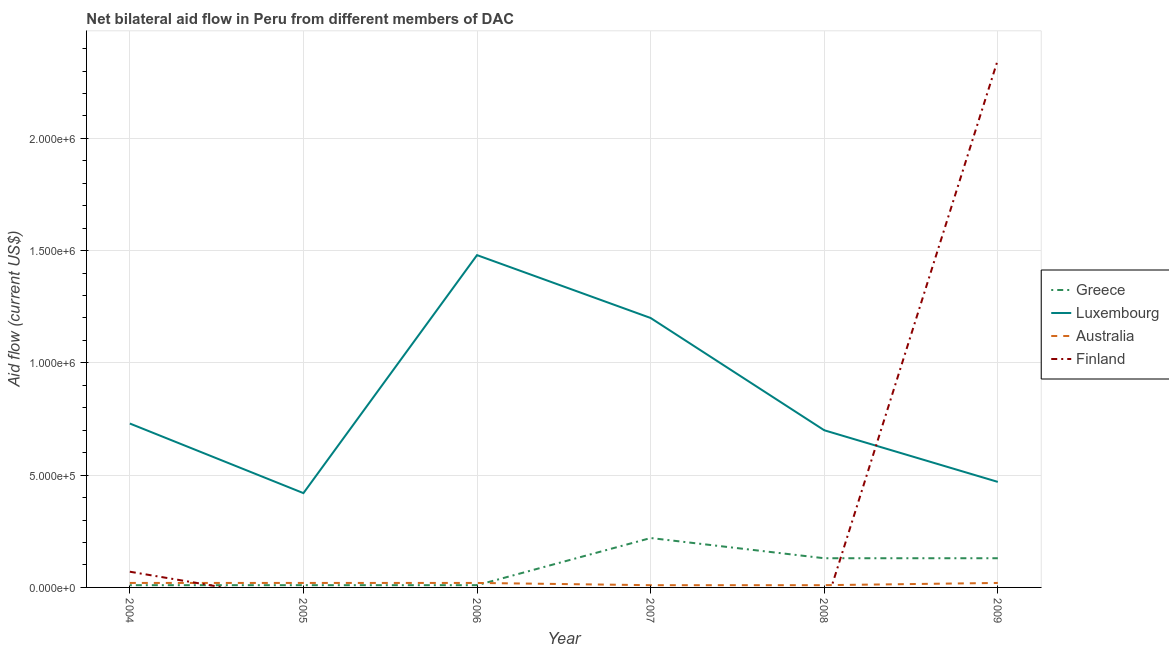Is the number of lines equal to the number of legend labels?
Your answer should be very brief. No. What is the amount of aid given by australia in 2009?
Offer a very short reply. 2.00e+04. Across all years, what is the maximum amount of aid given by greece?
Keep it short and to the point. 2.20e+05. Across all years, what is the minimum amount of aid given by greece?
Give a very brief answer. 10000. In which year was the amount of aid given by finland maximum?
Your answer should be very brief. 2009. What is the total amount of aid given by luxembourg in the graph?
Your answer should be very brief. 5.00e+06. What is the difference between the amount of aid given by luxembourg in 2005 and that in 2009?
Provide a succinct answer. -5.00e+04. What is the difference between the amount of aid given by australia in 2004 and the amount of aid given by greece in 2005?
Offer a terse response. 10000. What is the average amount of aid given by finland per year?
Your response must be concise. 4.03e+05. In the year 2004, what is the difference between the amount of aid given by australia and amount of aid given by greece?
Your answer should be compact. 10000. In how many years, is the amount of aid given by greece greater than 1400000 US$?
Keep it short and to the point. 0. What is the ratio of the amount of aid given by australia in 2005 to that in 2009?
Make the answer very short. 1. Is the amount of aid given by australia in 2004 less than that in 2007?
Your response must be concise. No. What is the difference between the highest and the second highest amount of aid given by greece?
Your answer should be compact. 9.00e+04. What is the difference between the highest and the lowest amount of aid given by australia?
Your answer should be compact. 10000. How many years are there in the graph?
Provide a short and direct response. 6. Are the values on the major ticks of Y-axis written in scientific E-notation?
Offer a very short reply. Yes. Does the graph contain any zero values?
Make the answer very short. Yes. Does the graph contain grids?
Provide a short and direct response. Yes. Where does the legend appear in the graph?
Your answer should be very brief. Center right. How many legend labels are there?
Ensure brevity in your answer.  4. How are the legend labels stacked?
Ensure brevity in your answer.  Vertical. What is the title of the graph?
Provide a short and direct response. Net bilateral aid flow in Peru from different members of DAC. Does "Terrestrial protected areas" appear as one of the legend labels in the graph?
Offer a very short reply. No. What is the label or title of the X-axis?
Give a very brief answer. Year. What is the Aid flow (current US$) of Greece in 2004?
Your answer should be very brief. 10000. What is the Aid flow (current US$) of Luxembourg in 2004?
Give a very brief answer. 7.30e+05. What is the Aid flow (current US$) in Greece in 2005?
Ensure brevity in your answer.  10000. What is the Aid flow (current US$) of Australia in 2005?
Keep it short and to the point. 2.00e+04. What is the Aid flow (current US$) of Greece in 2006?
Offer a very short reply. 10000. What is the Aid flow (current US$) in Luxembourg in 2006?
Keep it short and to the point. 1.48e+06. What is the Aid flow (current US$) of Australia in 2006?
Ensure brevity in your answer.  2.00e+04. What is the Aid flow (current US$) in Luxembourg in 2007?
Your answer should be very brief. 1.20e+06. What is the Aid flow (current US$) of Australia in 2007?
Provide a succinct answer. 10000. What is the Aid flow (current US$) of Finland in 2007?
Offer a very short reply. 0. What is the Aid flow (current US$) of Finland in 2008?
Ensure brevity in your answer.  0. What is the Aid flow (current US$) of Greece in 2009?
Ensure brevity in your answer.  1.30e+05. What is the Aid flow (current US$) of Finland in 2009?
Your answer should be very brief. 2.35e+06. Across all years, what is the maximum Aid flow (current US$) in Luxembourg?
Ensure brevity in your answer.  1.48e+06. Across all years, what is the maximum Aid flow (current US$) in Australia?
Your answer should be compact. 2.00e+04. Across all years, what is the maximum Aid flow (current US$) in Finland?
Make the answer very short. 2.35e+06. Across all years, what is the minimum Aid flow (current US$) of Luxembourg?
Provide a short and direct response. 4.20e+05. Across all years, what is the minimum Aid flow (current US$) of Australia?
Provide a short and direct response. 10000. Across all years, what is the minimum Aid flow (current US$) in Finland?
Offer a very short reply. 0. What is the total Aid flow (current US$) of Greece in the graph?
Give a very brief answer. 5.10e+05. What is the total Aid flow (current US$) of Luxembourg in the graph?
Keep it short and to the point. 5.00e+06. What is the total Aid flow (current US$) of Australia in the graph?
Keep it short and to the point. 1.00e+05. What is the total Aid flow (current US$) in Finland in the graph?
Your answer should be compact. 2.42e+06. What is the difference between the Aid flow (current US$) of Luxembourg in 2004 and that in 2006?
Provide a short and direct response. -7.50e+05. What is the difference between the Aid flow (current US$) of Australia in 2004 and that in 2006?
Your answer should be compact. 0. What is the difference between the Aid flow (current US$) of Greece in 2004 and that in 2007?
Your response must be concise. -2.10e+05. What is the difference between the Aid flow (current US$) in Luxembourg in 2004 and that in 2007?
Your answer should be compact. -4.70e+05. What is the difference between the Aid flow (current US$) of Australia in 2004 and that in 2007?
Give a very brief answer. 10000. What is the difference between the Aid flow (current US$) of Luxembourg in 2004 and that in 2008?
Keep it short and to the point. 3.00e+04. What is the difference between the Aid flow (current US$) in Australia in 2004 and that in 2008?
Your response must be concise. 10000. What is the difference between the Aid flow (current US$) of Greece in 2004 and that in 2009?
Give a very brief answer. -1.20e+05. What is the difference between the Aid flow (current US$) of Luxembourg in 2004 and that in 2009?
Your response must be concise. 2.60e+05. What is the difference between the Aid flow (current US$) in Finland in 2004 and that in 2009?
Your response must be concise. -2.28e+06. What is the difference between the Aid flow (current US$) of Luxembourg in 2005 and that in 2006?
Offer a terse response. -1.06e+06. What is the difference between the Aid flow (current US$) of Australia in 2005 and that in 2006?
Your response must be concise. 0. What is the difference between the Aid flow (current US$) of Luxembourg in 2005 and that in 2007?
Ensure brevity in your answer.  -7.80e+05. What is the difference between the Aid flow (current US$) in Australia in 2005 and that in 2007?
Keep it short and to the point. 10000. What is the difference between the Aid flow (current US$) in Greece in 2005 and that in 2008?
Your response must be concise. -1.20e+05. What is the difference between the Aid flow (current US$) in Luxembourg in 2005 and that in 2008?
Provide a succinct answer. -2.80e+05. What is the difference between the Aid flow (current US$) of Greece in 2005 and that in 2009?
Offer a very short reply. -1.20e+05. What is the difference between the Aid flow (current US$) in Luxembourg in 2005 and that in 2009?
Provide a succinct answer. -5.00e+04. What is the difference between the Aid flow (current US$) in Luxembourg in 2006 and that in 2007?
Ensure brevity in your answer.  2.80e+05. What is the difference between the Aid flow (current US$) of Australia in 2006 and that in 2007?
Make the answer very short. 10000. What is the difference between the Aid flow (current US$) of Greece in 2006 and that in 2008?
Make the answer very short. -1.20e+05. What is the difference between the Aid flow (current US$) of Luxembourg in 2006 and that in 2008?
Make the answer very short. 7.80e+05. What is the difference between the Aid flow (current US$) of Australia in 2006 and that in 2008?
Your answer should be compact. 10000. What is the difference between the Aid flow (current US$) in Luxembourg in 2006 and that in 2009?
Offer a very short reply. 1.01e+06. What is the difference between the Aid flow (current US$) in Australia in 2006 and that in 2009?
Your answer should be very brief. 0. What is the difference between the Aid flow (current US$) in Luxembourg in 2007 and that in 2009?
Give a very brief answer. 7.30e+05. What is the difference between the Aid flow (current US$) of Australia in 2007 and that in 2009?
Your response must be concise. -10000. What is the difference between the Aid flow (current US$) in Luxembourg in 2008 and that in 2009?
Ensure brevity in your answer.  2.30e+05. What is the difference between the Aid flow (current US$) of Australia in 2008 and that in 2009?
Provide a short and direct response. -10000. What is the difference between the Aid flow (current US$) in Greece in 2004 and the Aid flow (current US$) in Luxembourg in 2005?
Ensure brevity in your answer.  -4.10e+05. What is the difference between the Aid flow (current US$) in Greece in 2004 and the Aid flow (current US$) in Australia in 2005?
Your answer should be compact. -10000. What is the difference between the Aid flow (current US$) of Luxembourg in 2004 and the Aid flow (current US$) of Australia in 2005?
Offer a terse response. 7.10e+05. What is the difference between the Aid flow (current US$) in Greece in 2004 and the Aid flow (current US$) in Luxembourg in 2006?
Make the answer very short. -1.47e+06. What is the difference between the Aid flow (current US$) of Luxembourg in 2004 and the Aid flow (current US$) of Australia in 2006?
Ensure brevity in your answer.  7.10e+05. What is the difference between the Aid flow (current US$) in Greece in 2004 and the Aid flow (current US$) in Luxembourg in 2007?
Your answer should be compact. -1.19e+06. What is the difference between the Aid flow (current US$) in Greece in 2004 and the Aid flow (current US$) in Australia in 2007?
Ensure brevity in your answer.  0. What is the difference between the Aid flow (current US$) of Luxembourg in 2004 and the Aid flow (current US$) of Australia in 2007?
Provide a short and direct response. 7.20e+05. What is the difference between the Aid flow (current US$) of Greece in 2004 and the Aid flow (current US$) of Luxembourg in 2008?
Keep it short and to the point. -6.90e+05. What is the difference between the Aid flow (current US$) of Luxembourg in 2004 and the Aid flow (current US$) of Australia in 2008?
Provide a succinct answer. 7.20e+05. What is the difference between the Aid flow (current US$) of Greece in 2004 and the Aid flow (current US$) of Luxembourg in 2009?
Your response must be concise. -4.60e+05. What is the difference between the Aid flow (current US$) of Greece in 2004 and the Aid flow (current US$) of Finland in 2009?
Keep it short and to the point. -2.34e+06. What is the difference between the Aid flow (current US$) in Luxembourg in 2004 and the Aid flow (current US$) in Australia in 2009?
Your response must be concise. 7.10e+05. What is the difference between the Aid flow (current US$) of Luxembourg in 2004 and the Aid flow (current US$) of Finland in 2009?
Ensure brevity in your answer.  -1.62e+06. What is the difference between the Aid flow (current US$) in Australia in 2004 and the Aid flow (current US$) in Finland in 2009?
Keep it short and to the point. -2.33e+06. What is the difference between the Aid flow (current US$) in Greece in 2005 and the Aid flow (current US$) in Luxembourg in 2006?
Keep it short and to the point. -1.47e+06. What is the difference between the Aid flow (current US$) of Luxembourg in 2005 and the Aid flow (current US$) of Australia in 2006?
Offer a very short reply. 4.00e+05. What is the difference between the Aid flow (current US$) of Greece in 2005 and the Aid flow (current US$) of Luxembourg in 2007?
Provide a succinct answer. -1.19e+06. What is the difference between the Aid flow (current US$) of Luxembourg in 2005 and the Aid flow (current US$) of Australia in 2007?
Make the answer very short. 4.10e+05. What is the difference between the Aid flow (current US$) of Greece in 2005 and the Aid flow (current US$) of Luxembourg in 2008?
Provide a succinct answer. -6.90e+05. What is the difference between the Aid flow (current US$) in Luxembourg in 2005 and the Aid flow (current US$) in Australia in 2008?
Provide a short and direct response. 4.10e+05. What is the difference between the Aid flow (current US$) in Greece in 2005 and the Aid flow (current US$) in Luxembourg in 2009?
Offer a very short reply. -4.60e+05. What is the difference between the Aid flow (current US$) in Greece in 2005 and the Aid flow (current US$) in Finland in 2009?
Provide a succinct answer. -2.34e+06. What is the difference between the Aid flow (current US$) of Luxembourg in 2005 and the Aid flow (current US$) of Finland in 2009?
Your answer should be compact. -1.93e+06. What is the difference between the Aid flow (current US$) in Australia in 2005 and the Aid flow (current US$) in Finland in 2009?
Make the answer very short. -2.33e+06. What is the difference between the Aid flow (current US$) in Greece in 2006 and the Aid flow (current US$) in Luxembourg in 2007?
Your response must be concise. -1.19e+06. What is the difference between the Aid flow (current US$) of Greece in 2006 and the Aid flow (current US$) of Australia in 2007?
Provide a succinct answer. 0. What is the difference between the Aid flow (current US$) in Luxembourg in 2006 and the Aid flow (current US$) in Australia in 2007?
Your answer should be compact. 1.47e+06. What is the difference between the Aid flow (current US$) in Greece in 2006 and the Aid flow (current US$) in Luxembourg in 2008?
Provide a short and direct response. -6.90e+05. What is the difference between the Aid flow (current US$) of Greece in 2006 and the Aid flow (current US$) of Australia in 2008?
Provide a succinct answer. 0. What is the difference between the Aid flow (current US$) in Luxembourg in 2006 and the Aid flow (current US$) in Australia in 2008?
Keep it short and to the point. 1.47e+06. What is the difference between the Aid flow (current US$) in Greece in 2006 and the Aid flow (current US$) in Luxembourg in 2009?
Offer a very short reply. -4.60e+05. What is the difference between the Aid flow (current US$) in Greece in 2006 and the Aid flow (current US$) in Australia in 2009?
Offer a very short reply. -10000. What is the difference between the Aid flow (current US$) of Greece in 2006 and the Aid flow (current US$) of Finland in 2009?
Give a very brief answer. -2.34e+06. What is the difference between the Aid flow (current US$) of Luxembourg in 2006 and the Aid flow (current US$) of Australia in 2009?
Your answer should be very brief. 1.46e+06. What is the difference between the Aid flow (current US$) of Luxembourg in 2006 and the Aid flow (current US$) of Finland in 2009?
Provide a succinct answer. -8.70e+05. What is the difference between the Aid flow (current US$) in Australia in 2006 and the Aid flow (current US$) in Finland in 2009?
Your answer should be very brief. -2.33e+06. What is the difference between the Aid flow (current US$) of Greece in 2007 and the Aid flow (current US$) of Luxembourg in 2008?
Provide a succinct answer. -4.80e+05. What is the difference between the Aid flow (current US$) in Greece in 2007 and the Aid flow (current US$) in Australia in 2008?
Make the answer very short. 2.10e+05. What is the difference between the Aid flow (current US$) in Luxembourg in 2007 and the Aid flow (current US$) in Australia in 2008?
Give a very brief answer. 1.19e+06. What is the difference between the Aid flow (current US$) in Greece in 2007 and the Aid flow (current US$) in Australia in 2009?
Offer a terse response. 2.00e+05. What is the difference between the Aid flow (current US$) in Greece in 2007 and the Aid flow (current US$) in Finland in 2009?
Provide a succinct answer. -2.13e+06. What is the difference between the Aid flow (current US$) of Luxembourg in 2007 and the Aid flow (current US$) of Australia in 2009?
Your answer should be compact. 1.18e+06. What is the difference between the Aid flow (current US$) in Luxembourg in 2007 and the Aid flow (current US$) in Finland in 2009?
Ensure brevity in your answer.  -1.15e+06. What is the difference between the Aid flow (current US$) in Australia in 2007 and the Aid flow (current US$) in Finland in 2009?
Ensure brevity in your answer.  -2.34e+06. What is the difference between the Aid flow (current US$) in Greece in 2008 and the Aid flow (current US$) in Luxembourg in 2009?
Ensure brevity in your answer.  -3.40e+05. What is the difference between the Aid flow (current US$) in Greece in 2008 and the Aid flow (current US$) in Australia in 2009?
Give a very brief answer. 1.10e+05. What is the difference between the Aid flow (current US$) in Greece in 2008 and the Aid flow (current US$) in Finland in 2009?
Make the answer very short. -2.22e+06. What is the difference between the Aid flow (current US$) of Luxembourg in 2008 and the Aid flow (current US$) of Australia in 2009?
Keep it short and to the point. 6.80e+05. What is the difference between the Aid flow (current US$) in Luxembourg in 2008 and the Aid flow (current US$) in Finland in 2009?
Make the answer very short. -1.65e+06. What is the difference between the Aid flow (current US$) of Australia in 2008 and the Aid flow (current US$) of Finland in 2009?
Keep it short and to the point. -2.34e+06. What is the average Aid flow (current US$) in Greece per year?
Your answer should be compact. 8.50e+04. What is the average Aid flow (current US$) in Luxembourg per year?
Make the answer very short. 8.33e+05. What is the average Aid flow (current US$) of Australia per year?
Make the answer very short. 1.67e+04. What is the average Aid flow (current US$) in Finland per year?
Give a very brief answer. 4.03e+05. In the year 2004, what is the difference between the Aid flow (current US$) in Greece and Aid flow (current US$) in Luxembourg?
Give a very brief answer. -7.20e+05. In the year 2004, what is the difference between the Aid flow (current US$) of Greece and Aid flow (current US$) of Finland?
Ensure brevity in your answer.  -6.00e+04. In the year 2004, what is the difference between the Aid flow (current US$) of Luxembourg and Aid flow (current US$) of Australia?
Your answer should be compact. 7.10e+05. In the year 2004, what is the difference between the Aid flow (current US$) in Luxembourg and Aid flow (current US$) in Finland?
Give a very brief answer. 6.60e+05. In the year 2004, what is the difference between the Aid flow (current US$) in Australia and Aid flow (current US$) in Finland?
Your answer should be very brief. -5.00e+04. In the year 2005, what is the difference between the Aid flow (current US$) in Greece and Aid flow (current US$) in Luxembourg?
Offer a terse response. -4.10e+05. In the year 2005, what is the difference between the Aid flow (current US$) in Luxembourg and Aid flow (current US$) in Australia?
Provide a succinct answer. 4.00e+05. In the year 2006, what is the difference between the Aid flow (current US$) in Greece and Aid flow (current US$) in Luxembourg?
Provide a succinct answer. -1.47e+06. In the year 2006, what is the difference between the Aid flow (current US$) of Luxembourg and Aid flow (current US$) of Australia?
Offer a terse response. 1.46e+06. In the year 2007, what is the difference between the Aid flow (current US$) of Greece and Aid flow (current US$) of Luxembourg?
Make the answer very short. -9.80e+05. In the year 2007, what is the difference between the Aid flow (current US$) of Luxembourg and Aid flow (current US$) of Australia?
Make the answer very short. 1.19e+06. In the year 2008, what is the difference between the Aid flow (current US$) in Greece and Aid flow (current US$) in Luxembourg?
Offer a terse response. -5.70e+05. In the year 2008, what is the difference between the Aid flow (current US$) of Luxembourg and Aid flow (current US$) of Australia?
Give a very brief answer. 6.90e+05. In the year 2009, what is the difference between the Aid flow (current US$) in Greece and Aid flow (current US$) in Australia?
Keep it short and to the point. 1.10e+05. In the year 2009, what is the difference between the Aid flow (current US$) of Greece and Aid flow (current US$) of Finland?
Make the answer very short. -2.22e+06. In the year 2009, what is the difference between the Aid flow (current US$) in Luxembourg and Aid flow (current US$) in Australia?
Ensure brevity in your answer.  4.50e+05. In the year 2009, what is the difference between the Aid flow (current US$) of Luxembourg and Aid flow (current US$) of Finland?
Your answer should be compact. -1.88e+06. In the year 2009, what is the difference between the Aid flow (current US$) in Australia and Aid flow (current US$) in Finland?
Offer a terse response. -2.33e+06. What is the ratio of the Aid flow (current US$) in Greece in 2004 to that in 2005?
Make the answer very short. 1. What is the ratio of the Aid flow (current US$) in Luxembourg in 2004 to that in 2005?
Make the answer very short. 1.74. What is the ratio of the Aid flow (current US$) in Australia in 2004 to that in 2005?
Give a very brief answer. 1. What is the ratio of the Aid flow (current US$) of Greece in 2004 to that in 2006?
Provide a succinct answer. 1. What is the ratio of the Aid flow (current US$) of Luxembourg in 2004 to that in 2006?
Your response must be concise. 0.49. What is the ratio of the Aid flow (current US$) of Australia in 2004 to that in 2006?
Give a very brief answer. 1. What is the ratio of the Aid flow (current US$) of Greece in 2004 to that in 2007?
Provide a succinct answer. 0.05. What is the ratio of the Aid flow (current US$) of Luxembourg in 2004 to that in 2007?
Offer a terse response. 0.61. What is the ratio of the Aid flow (current US$) of Australia in 2004 to that in 2007?
Offer a very short reply. 2. What is the ratio of the Aid flow (current US$) of Greece in 2004 to that in 2008?
Your response must be concise. 0.08. What is the ratio of the Aid flow (current US$) in Luxembourg in 2004 to that in 2008?
Ensure brevity in your answer.  1.04. What is the ratio of the Aid flow (current US$) in Greece in 2004 to that in 2009?
Your response must be concise. 0.08. What is the ratio of the Aid flow (current US$) in Luxembourg in 2004 to that in 2009?
Your answer should be very brief. 1.55. What is the ratio of the Aid flow (current US$) in Finland in 2004 to that in 2009?
Offer a very short reply. 0.03. What is the ratio of the Aid flow (current US$) of Greece in 2005 to that in 2006?
Offer a terse response. 1. What is the ratio of the Aid flow (current US$) of Luxembourg in 2005 to that in 2006?
Ensure brevity in your answer.  0.28. What is the ratio of the Aid flow (current US$) in Greece in 2005 to that in 2007?
Your response must be concise. 0.05. What is the ratio of the Aid flow (current US$) of Australia in 2005 to that in 2007?
Offer a terse response. 2. What is the ratio of the Aid flow (current US$) in Greece in 2005 to that in 2008?
Your response must be concise. 0.08. What is the ratio of the Aid flow (current US$) of Greece in 2005 to that in 2009?
Make the answer very short. 0.08. What is the ratio of the Aid flow (current US$) in Luxembourg in 2005 to that in 2009?
Provide a short and direct response. 0.89. What is the ratio of the Aid flow (current US$) of Australia in 2005 to that in 2009?
Make the answer very short. 1. What is the ratio of the Aid flow (current US$) of Greece in 2006 to that in 2007?
Ensure brevity in your answer.  0.05. What is the ratio of the Aid flow (current US$) in Luxembourg in 2006 to that in 2007?
Offer a very short reply. 1.23. What is the ratio of the Aid flow (current US$) of Greece in 2006 to that in 2008?
Your answer should be very brief. 0.08. What is the ratio of the Aid flow (current US$) in Luxembourg in 2006 to that in 2008?
Ensure brevity in your answer.  2.11. What is the ratio of the Aid flow (current US$) of Australia in 2006 to that in 2008?
Keep it short and to the point. 2. What is the ratio of the Aid flow (current US$) in Greece in 2006 to that in 2009?
Your answer should be compact. 0.08. What is the ratio of the Aid flow (current US$) of Luxembourg in 2006 to that in 2009?
Ensure brevity in your answer.  3.15. What is the ratio of the Aid flow (current US$) in Greece in 2007 to that in 2008?
Provide a short and direct response. 1.69. What is the ratio of the Aid flow (current US$) in Luxembourg in 2007 to that in 2008?
Make the answer very short. 1.71. What is the ratio of the Aid flow (current US$) in Greece in 2007 to that in 2009?
Provide a succinct answer. 1.69. What is the ratio of the Aid flow (current US$) in Luxembourg in 2007 to that in 2009?
Offer a very short reply. 2.55. What is the ratio of the Aid flow (current US$) in Greece in 2008 to that in 2009?
Your answer should be compact. 1. What is the ratio of the Aid flow (current US$) of Luxembourg in 2008 to that in 2009?
Your answer should be compact. 1.49. What is the difference between the highest and the second highest Aid flow (current US$) in Luxembourg?
Keep it short and to the point. 2.80e+05. What is the difference between the highest and the second highest Aid flow (current US$) of Australia?
Offer a very short reply. 0. What is the difference between the highest and the lowest Aid flow (current US$) in Greece?
Keep it short and to the point. 2.10e+05. What is the difference between the highest and the lowest Aid flow (current US$) in Luxembourg?
Your response must be concise. 1.06e+06. What is the difference between the highest and the lowest Aid flow (current US$) of Australia?
Your response must be concise. 10000. What is the difference between the highest and the lowest Aid flow (current US$) in Finland?
Your answer should be compact. 2.35e+06. 